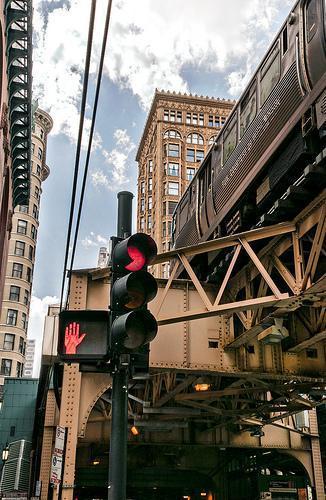How many power lines are in the sky?
Give a very brief answer. 2. 